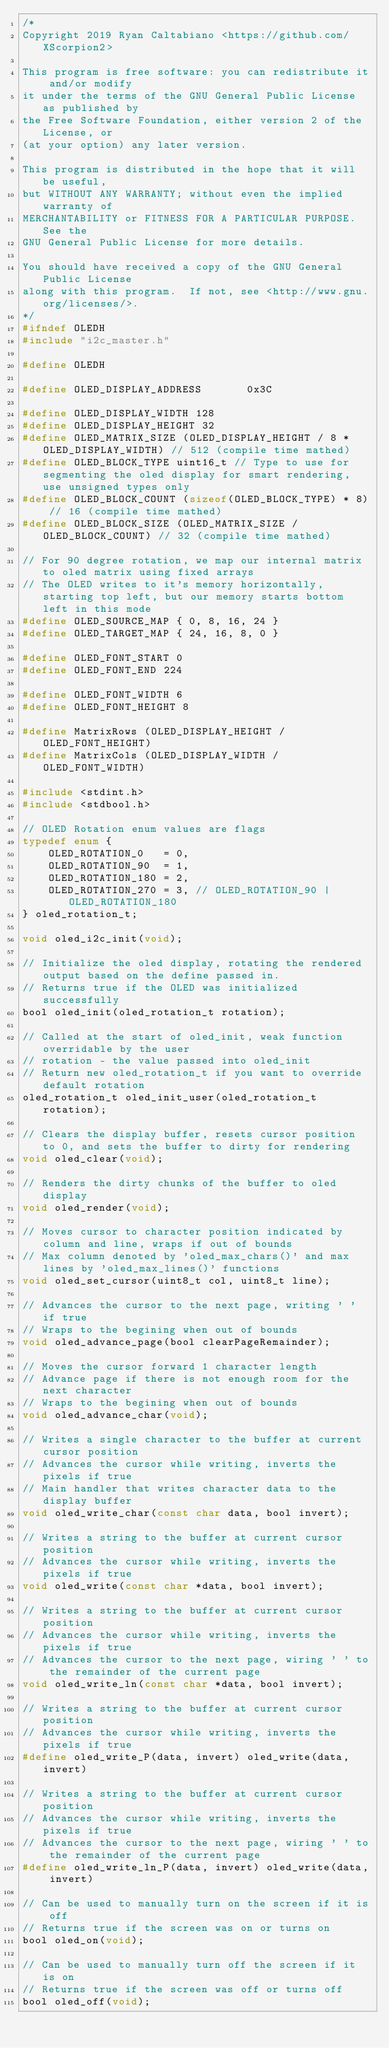Convert code to text. <code><loc_0><loc_0><loc_500><loc_500><_C_>/*
Copyright 2019 Ryan Caltabiano <https://github.com/XScorpion2>

This program is free software: you can redistribute it and/or modify
it under the terms of the GNU General Public License as published by
the Free Software Foundation, either version 2 of the License, or
(at your option) any later version.

This program is distributed in the hope that it will be useful,
but WITHOUT ANY WARRANTY; without even the implied warranty of
MERCHANTABILITY or FITNESS FOR A PARTICULAR PURPOSE.  See the
GNU General Public License for more details.

You should have received a copy of the GNU General Public License
along with this program.  If not, see <http://www.gnu.org/licenses/>.
*/
#ifndef OLEDH
#include "i2c_master.h"

#define OLEDH

#define OLED_DISPLAY_ADDRESS       0x3C

#define OLED_DISPLAY_WIDTH 128
#define OLED_DISPLAY_HEIGHT 32
#define OLED_MATRIX_SIZE (OLED_DISPLAY_HEIGHT / 8 * OLED_DISPLAY_WIDTH) // 512 (compile time mathed)
#define OLED_BLOCK_TYPE uint16_t // Type to use for segmenting the oled display for smart rendering, use unsigned types only
#define OLED_BLOCK_COUNT (sizeof(OLED_BLOCK_TYPE) * 8) // 16 (compile time mathed)
#define OLED_BLOCK_SIZE (OLED_MATRIX_SIZE / OLED_BLOCK_COUNT) // 32 (compile time mathed)

// For 90 degree rotation, we map our internal matrix to oled matrix using fixed arrays
// The OLED writes to it's memory horizontally, starting top left, but our memory starts bottom left in this mode
#define OLED_SOURCE_MAP { 0, 8, 16, 24 }
#define OLED_TARGET_MAP { 24, 16, 8, 0 }

#define OLED_FONT_START 0
#define OLED_FONT_END 224

#define OLED_FONT_WIDTH 6
#define OLED_FONT_HEIGHT 8

#define MatrixRows (OLED_DISPLAY_HEIGHT / OLED_FONT_HEIGHT)
#define MatrixCols (OLED_DISPLAY_WIDTH / OLED_FONT_WIDTH)

#include <stdint.h>
#include <stdbool.h>

// OLED Rotation enum values are flags
typedef enum {
    OLED_ROTATION_0   = 0,
    OLED_ROTATION_90  = 1,
    OLED_ROTATION_180 = 2,
    OLED_ROTATION_270 = 3, // OLED_ROTATION_90 | OLED_ROTATION_180
} oled_rotation_t;

void oled_i2c_init(void);

// Initialize the oled display, rotating the rendered output based on the define passed in.
// Returns true if the OLED was initialized successfully
bool oled_init(oled_rotation_t rotation);

// Called at the start of oled_init, weak function overridable by the user
// rotation - the value passed into oled_init
// Return new oled_rotation_t if you want to override default rotation
oled_rotation_t oled_init_user(oled_rotation_t rotation);

// Clears the display buffer, resets cursor position to 0, and sets the buffer to dirty for rendering
void oled_clear(void);

// Renders the dirty chunks of the buffer to oled display
void oled_render(void);

// Moves cursor to character position indicated by column and line, wraps if out of bounds
// Max column denoted by 'oled_max_chars()' and max lines by 'oled_max_lines()' functions
void oled_set_cursor(uint8_t col, uint8_t line);

// Advances the cursor to the next page, writing ' ' if true
// Wraps to the begining when out of bounds
void oled_advance_page(bool clearPageRemainder);

// Moves the cursor forward 1 character length
// Advance page if there is not enough room for the next character
// Wraps to the begining when out of bounds
void oled_advance_char(void);

// Writes a single character to the buffer at current cursor position
// Advances the cursor while writing, inverts the pixels if true
// Main handler that writes character data to the display buffer
void oled_write_char(const char data, bool invert);

// Writes a string to the buffer at current cursor position
// Advances the cursor while writing, inverts the pixels if true
void oled_write(const char *data, bool invert);

// Writes a string to the buffer at current cursor position
// Advances the cursor while writing, inverts the pixels if true
// Advances the cursor to the next page, wiring ' ' to the remainder of the current page
void oled_write_ln(const char *data, bool invert);

// Writes a string to the buffer at current cursor position
// Advances the cursor while writing, inverts the pixels if true
#define oled_write_P(data, invert) oled_write(data, invert)

// Writes a string to the buffer at current cursor position
// Advances the cursor while writing, inverts the pixels if true
// Advances the cursor to the next page, wiring ' ' to the remainder of the current page
#define oled_write_ln_P(data, invert) oled_write(data, invert)

// Can be used to manually turn on the screen if it is off
// Returns true if the screen was on or turns on
bool oled_on(void);

// Can be used to manually turn off the screen if it is on
// Returns true if the screen was off or turns off
bool oled_off(void);
</code> 